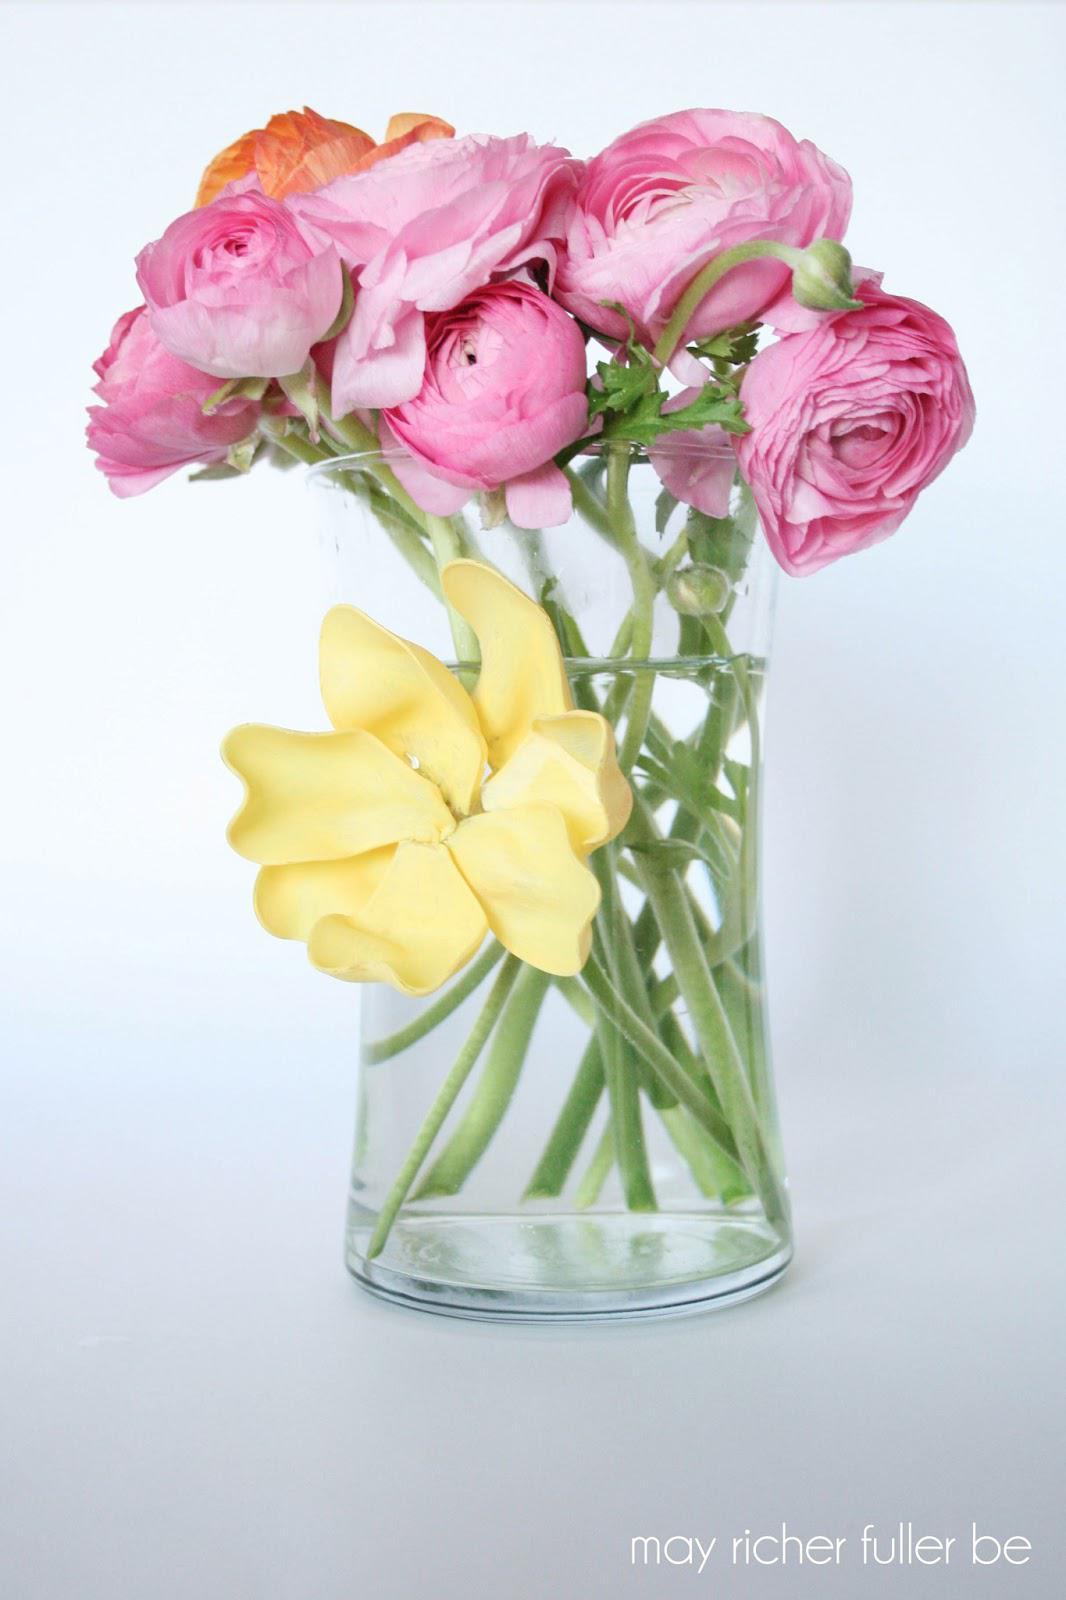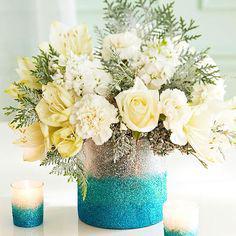The first image is the image on the left, the second image is the image on the right. For the images displayed, is the sentence "The left image features a clear vase containing several pink roses and one orange one, and the vase has a solid-colored flower on its front." factually correct? Answer yes or no. Yes. 